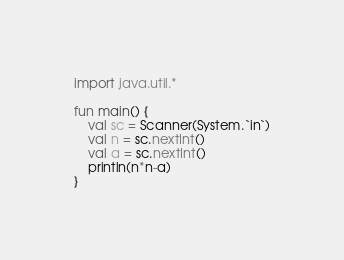<code> <loc_0><loc_0><loc_500><loc_500><_Kotlin_>import java.util.*

fun main() {
    val sc = Scanner(System.`in`)
    val n = sc.nextInt()
    val a = sc.nextInt()
    println(n*n-a)
}</code> 